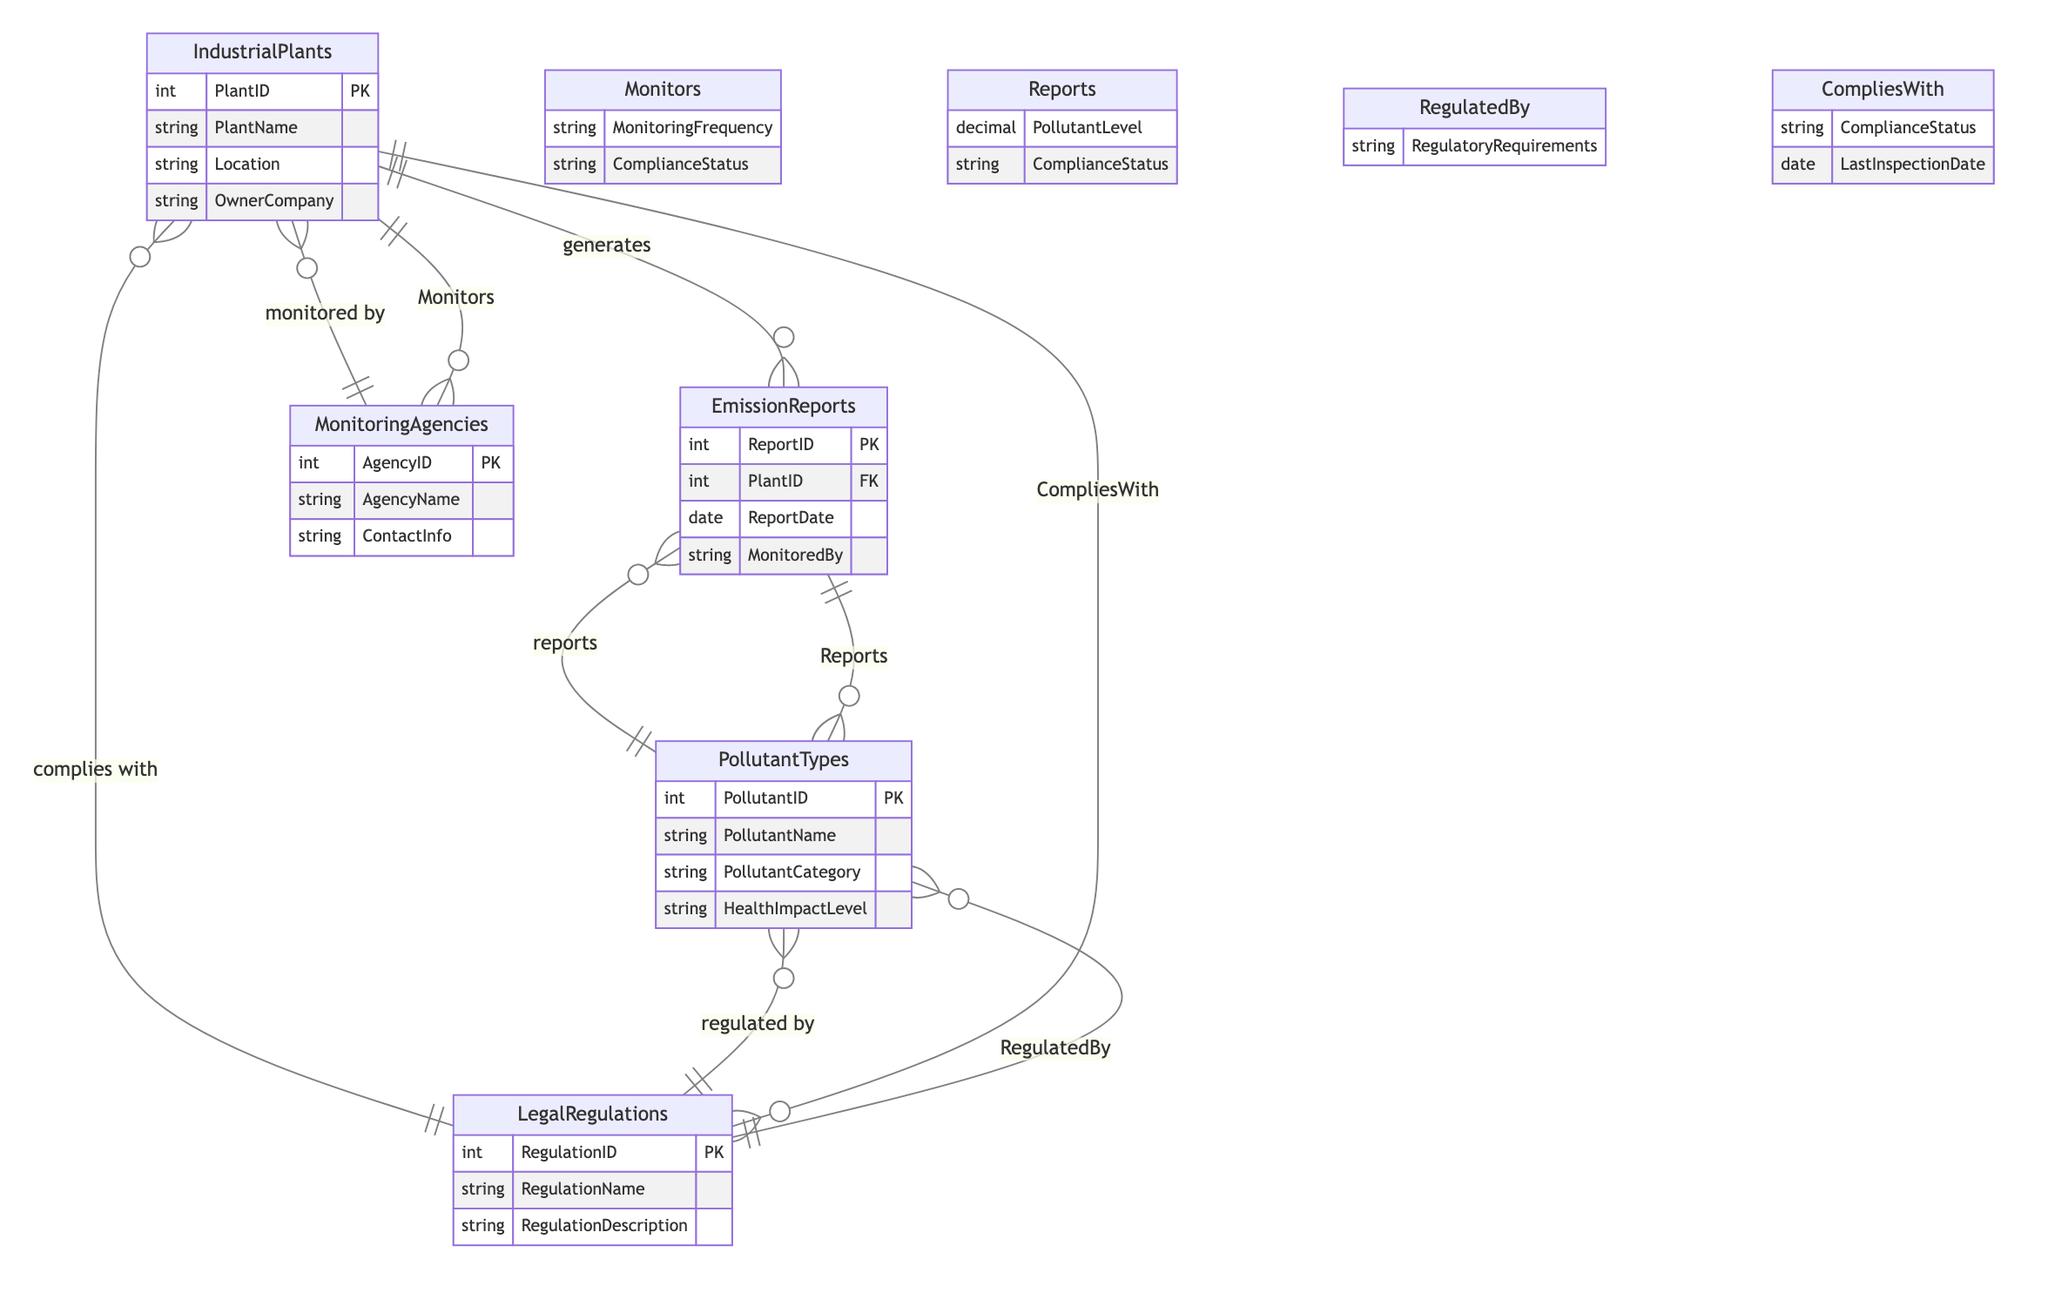What entities are present in the diagram? The diagram consists of five entities: Industrial Plants, Emission Reports, Pollutant Types, Monitoring Agencies, and Legal Regulations.
Answer: Industrial Plants, Emission Reports, Pollutant Types, Monitoring Agencies, Legal Regulations How many attributes does the Emission Reports entity have? The Emission Reports entity has four attributes: ReportID, PlantID, ReportDate, and MonitoredBy.
Answer: 4 What is the relationship between Monitoring Agencies and Industrial Plants? The relationship between Monitoring Agencies and Industrial Plants is through the "monitors" relationship. Monitoring Agencies monitor the Industrial Plants.
Answer: monitors What is a required attribute for the Pollutant Types entity? A required attribute for the Pollutant Types entity is PollutantName, which identifies the type of pollutant.
Answer: PollutantName How does Compliance Status connect Industrial Plants to Legal Regulations? The Compliance Status connects Industrial Plants to Legal Regulations through the "complies with" relationship, indicating whether the industrial plant meets legal requirements.
Answer: complies with Which entity reports on pollutant levels? The Emission Reports entity reports on pollutant levels, connecting to Pollutant Types through the "reports" relationship.
Answer: Emission Reports What attribute indicates the frequency of monitoring? The attribute that indicates the frequency of monitoring is MonitoringFrequency, found in the "monitors" relationship between Monitoring Agencies and Industrial Plants.
Answer: MonitoringFrequency How many relationships connect the Pollutant Types entity? The Pollutant Types entity is connected by three relationships: "reports," "regulated by," and indirectly connects through "complies with."
Answer: 3 What does the attribute RegulatoryRequirements describe? The RegulatoryRequirements attribute describes the requirements imposed by Legal Regulations on Pollutant Types, specifying compliance guidelines.
Answer: guidelines 